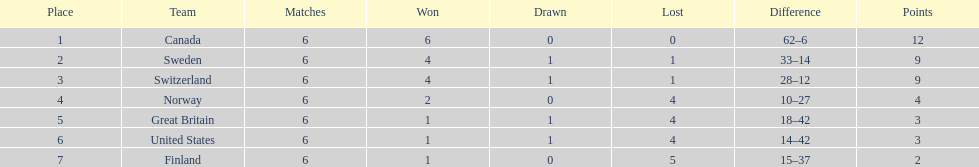What are the different countries called? Canada, Sweden, Switzerland, Norway, Great Britain, United States, Finland. Parse the full table in json format. {'header': ['Place', 'Team', 'Matches', 'Won', 'Drawn', 'Lost', 'Difference', 'Points'], 'rows': [['1', 'Canada', '6', '6', '0', '0', '62–6', '12'], ['2', 'Sweden', '6', '4', '1', '1', '33–14', '9'], ['3', 'Switzerland', '6', '4', '1', '1', '28–12', '9'], ['4', 'Norway', '6', '2', '0', '4', '10–27', '4'], ['5', 'Great Britain', '6', '1', '1', '4', '18–42', '3'], ['6', 'United States', '6', '1', '1', '4', '14–42', '3'], ['7', 'Finland', '6', '1', '0', '5', '15–37', '2']]} How many wins can be attributed to switzerland? 4. What is the total number of wins for great britain? 1. Comparing the two, did great britain or switzerland have more victories? Switzerland. 